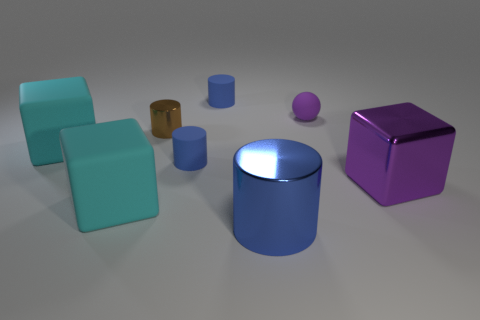Subtract all blue cylinders. How many were subtracted if there are1blue cylinders left? 2 Subtract all purple spheres. How many blue cylinders are left? 3 Add 2 small brown things. How many objects exist? 10 Subtract all cubes. How many objects are left? 5 Subtract all large purple metal cylinders. Subtract all purple metallic things. How many objects are left? 7 Add 4 tiny rubber things. How many tiny rubber things are left? 7 Add 8 big green metallic blocks. How many big green metallic blocks exist? 8 Subtract 0 yellow spheres. How many objects are left? 8 